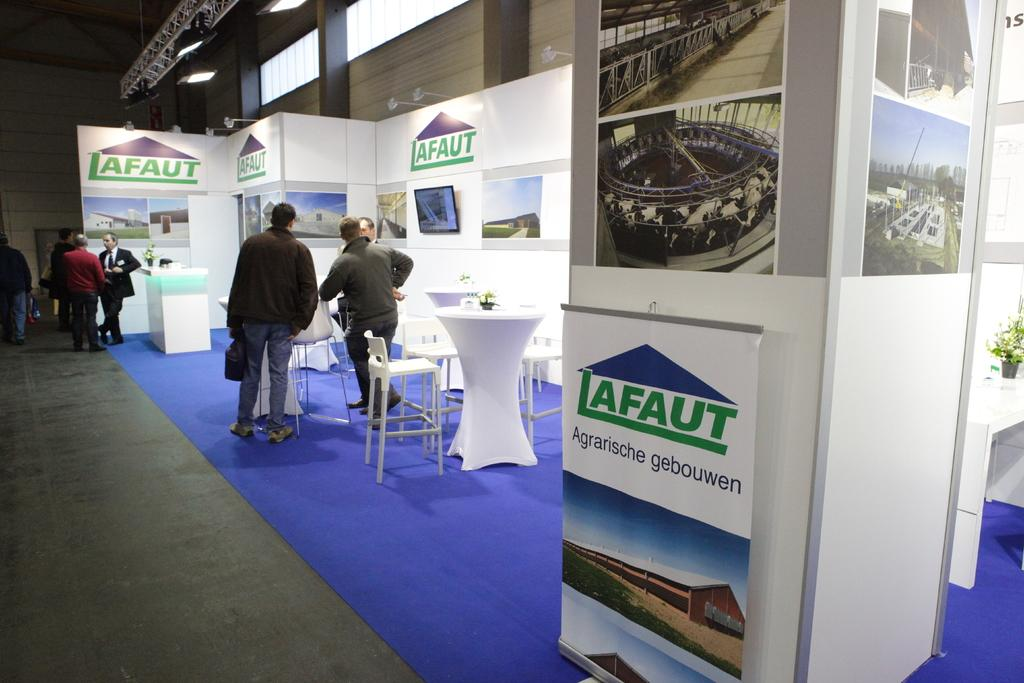<image>
Relay a brief, clear account of the picture shown. Afaut is on a sign that is hung on the wall 